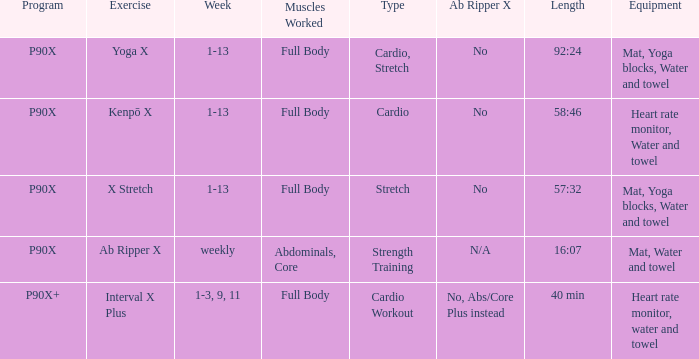How many types are cardio? 1.0. 